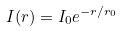Convert formula to latex. <formula><loc_0><loc_0><loc_500><loc_500>I ( r ) = I _ { 0 } e ^ { - r / r _ { 0 } }</formula> 